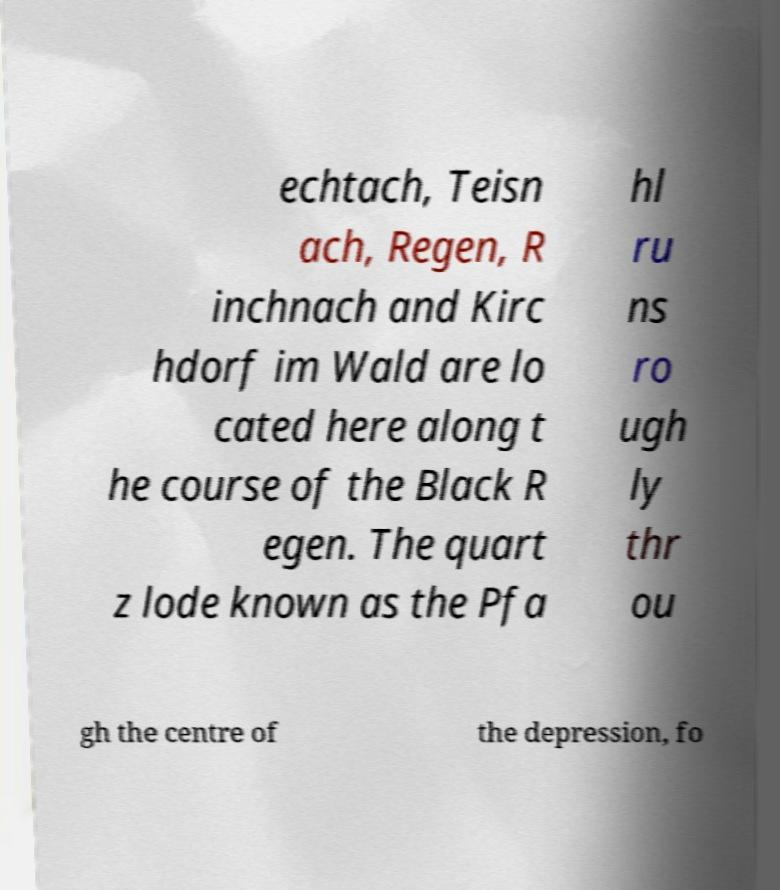For documentation purposes, I need the text within this image transcribed. Could you provide that? echtach, Teisn ach, Regen, R inchnach and Kirc hdorf im Wald are lo cated here along t he course of the Black R egen. The quart z lode known as the Pfa hl ru ns ro ugh ly thr ou gh the centre of the depression, fo 